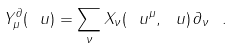<formula> <loc_0><loc_0><loc_500><loc_500>Y _ { \mu } ^ { \partial } ( \ u ) = \sum _ { \nu } X _ { \nu } ( \ u ^ { \mu } , \ u ) \, \partial _ { \nu } \ .</formula> 